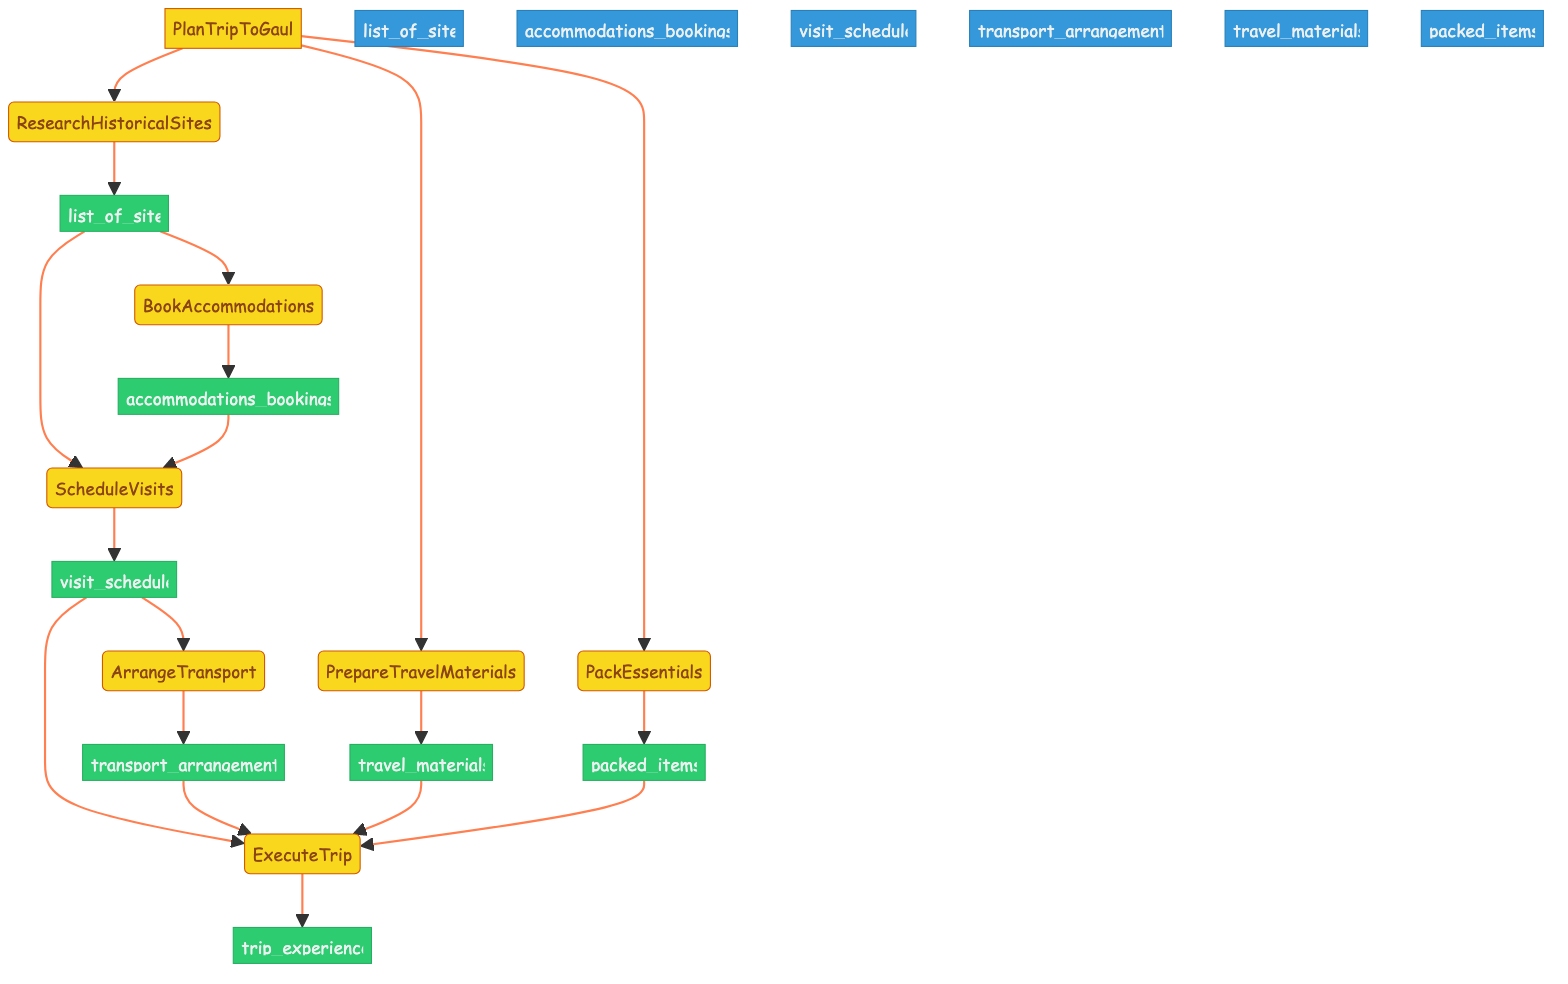What is the first step in planning the trip? The first step in the flowchart is labeled "ResearchHistoricalSites," which indicates it's the initial action to identify relevant historical sites related to Asterix.
Answer: ResearchHistoricalSites How many outputs are produced in total? Counting the outputs listed in the flowchart, we find that there are seven outputs (list_of_sites, accommodations_bookings, visit_schedule, transport_arrangements, travel_materials, packed_items, and trip_experience).
Answer: Seven What is the input to 'ScheduleVisits'? The input required for the 'ScheduleVisits' step includes a list of sites and the accommodations bookings, as indicated by the incoming arrows pointing to this node in the flowchart.
Answer: list_of_sites, accommodations_bookings Which steps generate output? The steps that produce output in the flowchart include ResearchHistoricalSites, BookAccommodations, ScheduleVisits, ArrangeTransport, PrepareTravelMaterials, PackEssentials, and ExecuteTrip.
Answer: Seven steps What do you need to pack for the trip? According to the flowchart, the step 'PackEssentials' will provide the output of packed items, which includes Asterix comics among other essentials for the trip.
Answer: packed_items What are the relationships between 'PrepareTravelMaterials' and 'ExecuteTrip'? 'PrepareTravelMaterials' serves as a precursor step to 'ExecuteTrip,' providing 'travel_materials' as an input to that step, indicating a dependency in the order of tasks.
Answer: travel_materials What are the outputs from the function 'PlanTripToGaul'? The outputs from the function include list_of_sites, accommodations_bookings, visit_schedule, transport_arrangements, travel_materials, packed_items, and trip_experience.
Answer: All seven outputs 